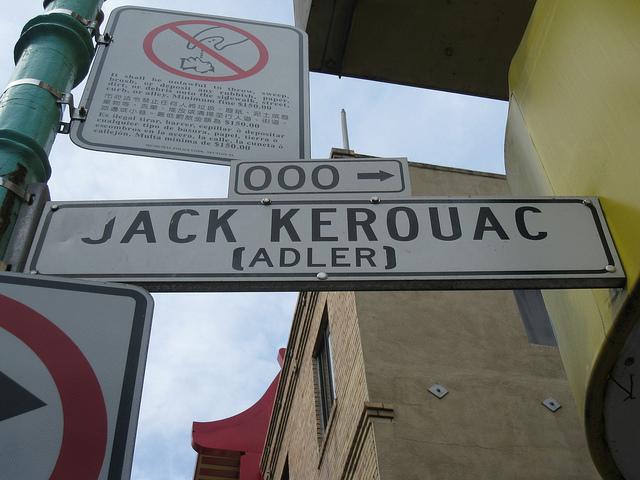Which way is the arrow pointing?
Write a very short answer. Right. What color are the signs?
Write a very short answer. White. What language is on the top sign?
Write a very short answer. English. What is the street name?
Concise answer only. Jack kerouac. Is the back of the photo blurred?
Quick response, please. No. 